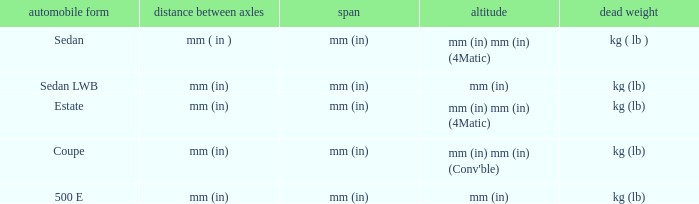What's the length of the model with 500 E body style? Mm (in). 